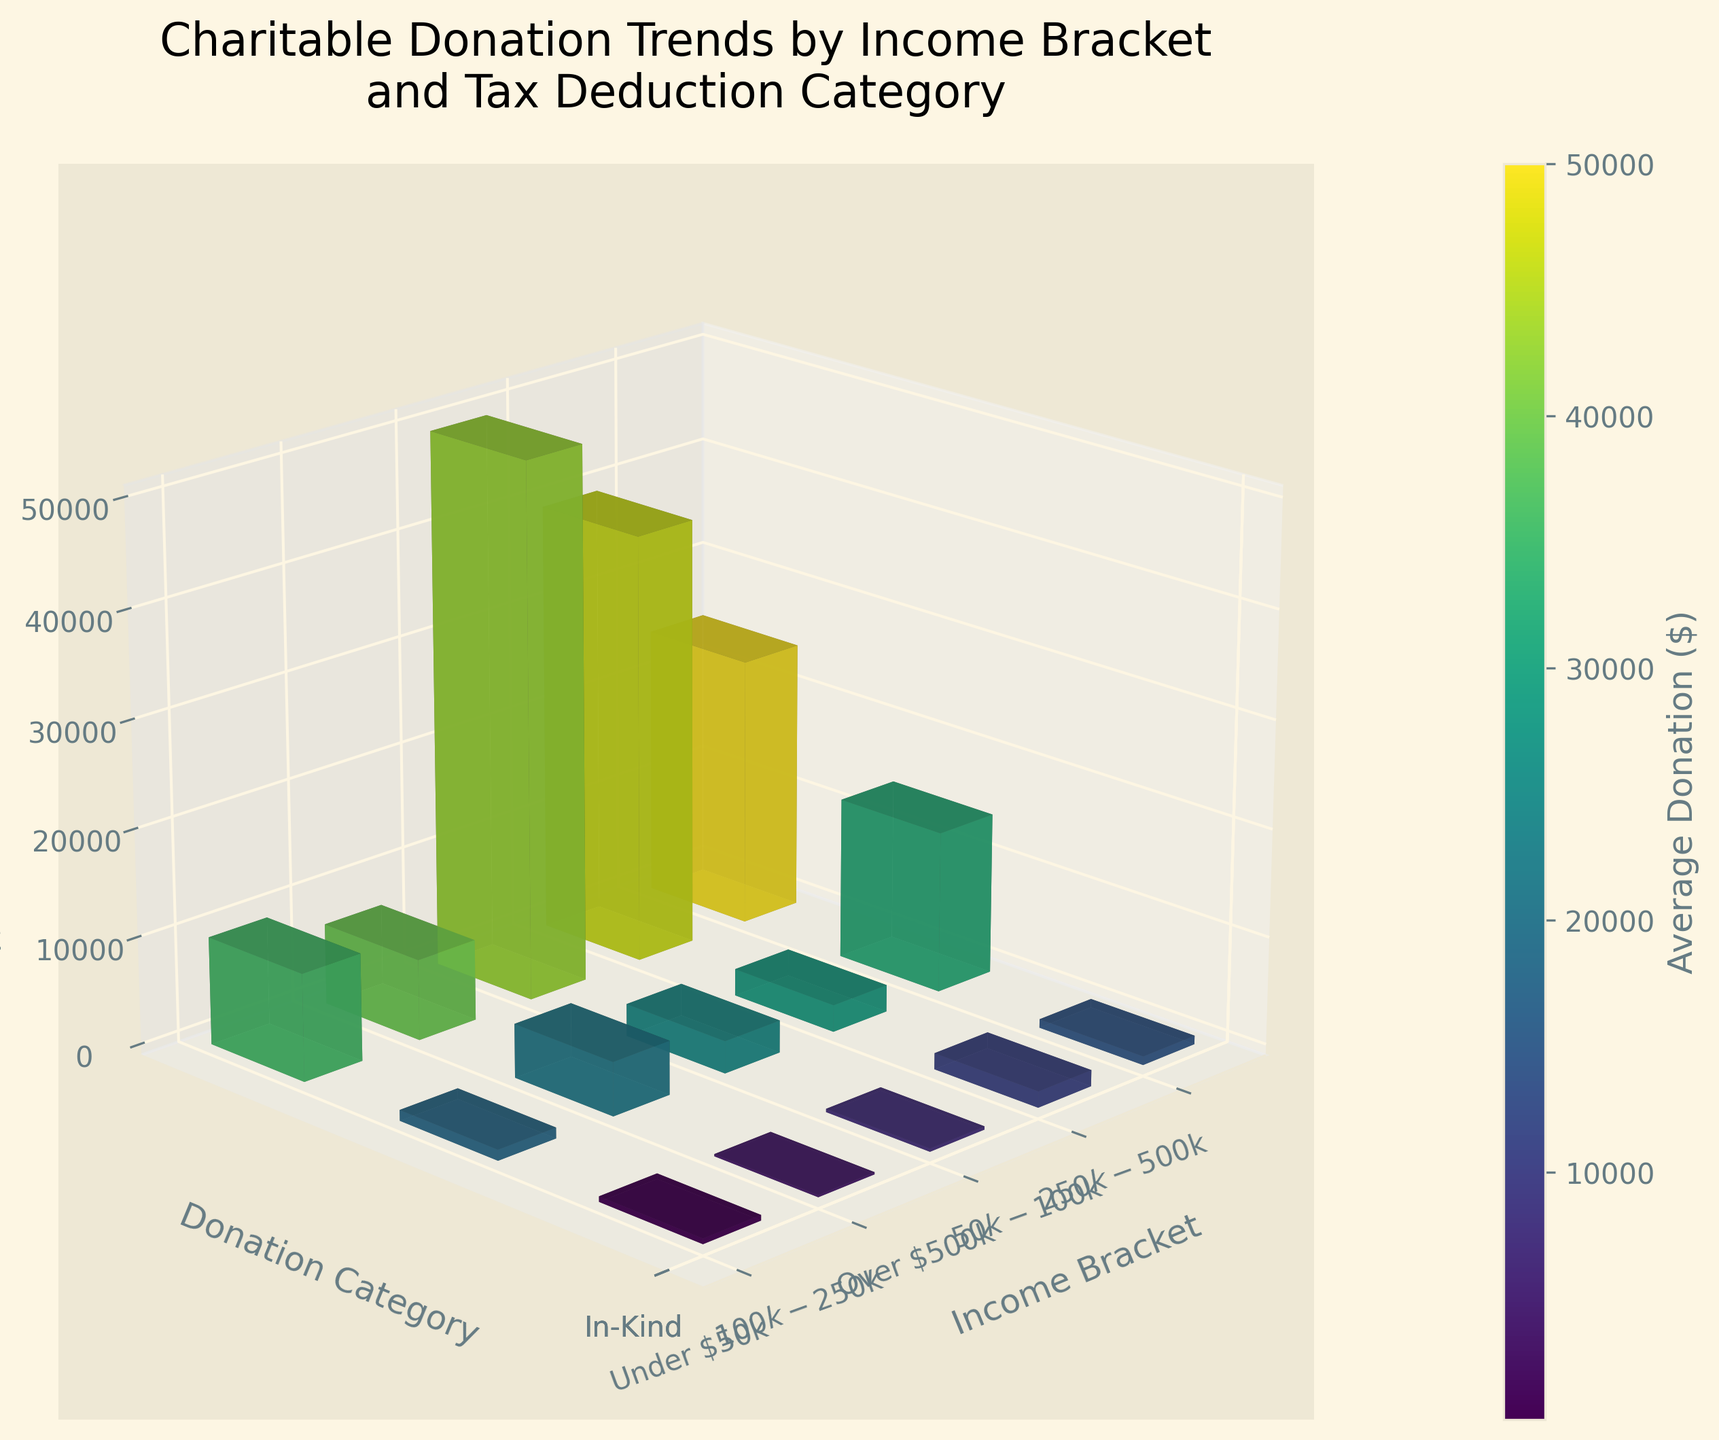What is the title of the plot? The title is usually located at the top of the plot. Reading it provides direct information about the main topic of the figure.
Answer: Charitable Donation Trends by Income Bracket and Tax Deduction Category What are the labels for the X, Y, and Z axes? These labels are typically shown next to the respective axes to describe what each axis represents.
Answer: Income Bracket, Donation Category, Average Donation ($) Which income bracket has the highest average cash donation? Look for the tallest bar in the 'Cash' category and note its corresponding income bracket.
Answer: Over $500k How many donation categories are represented in the plot? Read the Y-axis ticks to count the number of different donation categories.
Answer: 3 Which donation category has the lowest average donation for the $50k-$100k income bracket? Identify and compare the heights of the bars in each donation category (Cash, Stocks, In-Kind) for the specified income bracket.
Answer: Stocks What is the combined average donation for the $100k-$250k income bracket across all categories? Add the average donations for Cash, Stocks, and In-Kind in the $100k-$250k income bracket: 5000 + 3000 + 2500.
Answer: 10500 Which donation category shows the largest increase in average donation from the $250k-$500k to the Over $500k income bracket? Compare the average donations in each category (Cash, Stocks, In-Kind) between the two income brackets and find the one with the largest difference.
Answer: Cash How does the average donation for Stocks in the $250k-$500k income bracket compare to the average donation for Cash in the $50k-$100k income bracket? Compare the heights of the bars for Stocks in the $250k-$500k income bracket and Cash in the $50k-$100k income bracket directly.
Answer: The average donation for Stocks ($250k-$500k) is higher What is the average donation ratio between Cash and Stocks for those earning more than $500k? Divide the average donation for Cash by the average donation for Stocks in the Over $500k income bracket: 50000 / 40000.
Answer: 1.25 